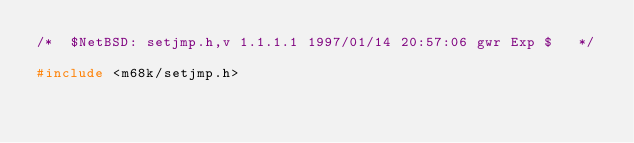<code> <loc_0><loc_0><loc_500><loc_500><_C_>/*	$NetBSD: setjmp.h,v 1.1.1.1 1997/01/14 20:57:06 gwr Exp $	*/

#include <m68k/setjmp.h>
</code> 